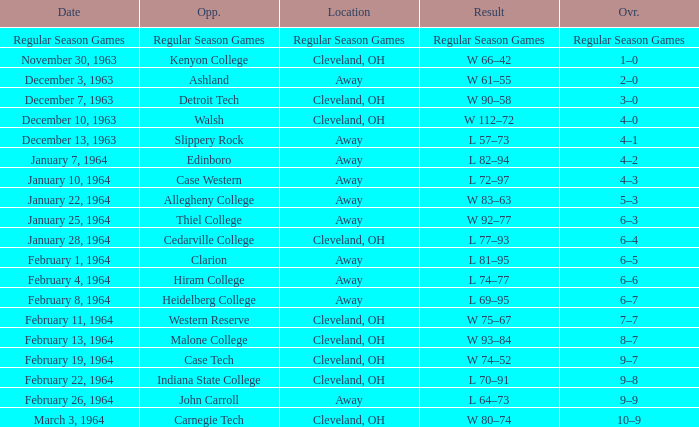What is the Date with an Opponent that is indiana state college? February 22, 1964. 